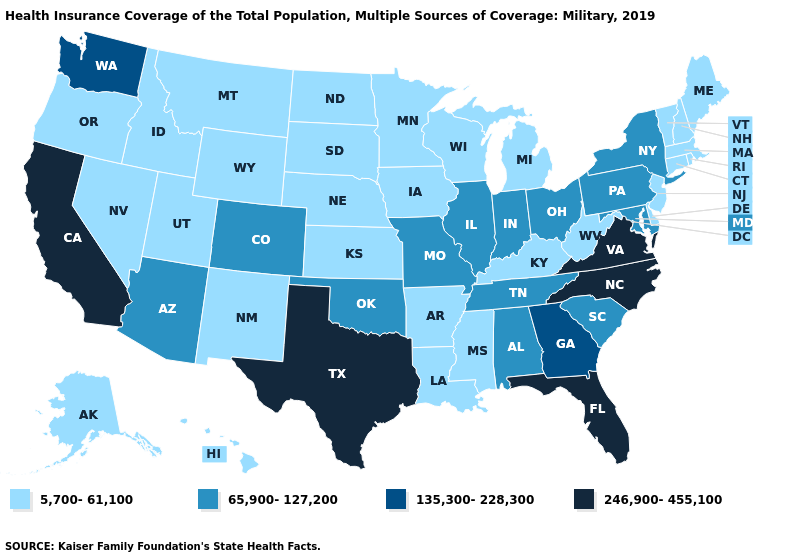What is the highest value in states that border Georgia?
Quick response, please. 246,900-455,100. What is the value of New Jersey?
Short answer required. 5,700-61,100. Does West Virginia have a lower value than Rhode Island?
Concise answer only. No. Name the states that have a value in the range 135,300-228,300?
Be succinct. Georgia, Washington. What is the value of West Virginia?
Write a very short answer. 5,700-61,100. What is the lowest value in states that border Vermont?
Write a very short answer. 5,700-61,100. What is the value of New Hampshire?
Concise answer only. 5,700-61,100. Among the states that border Tennessee , which have the lowest value?
Quick response, please. Arkansas, Kentucky, Mississippi. Which states hav the highest value in the MidWest?
Quick response, please. Illinois, Indiana, Missouri, Ohio. Among the states that border Massachusetts , does New York have the lowest value?
Quick response, please. No. Does Colorado have a higher value than Arkansas?
Write a very short answer. Yes. Which states have the highest value in the USA?
Short answer required. California, Florida, North Carolina, Texas, Virginia. What is the value of North Carolina?
Keep it brief. 246,900-455,100. What is the value of Kentucky?
Answer briefly. 5,700-61,100. 